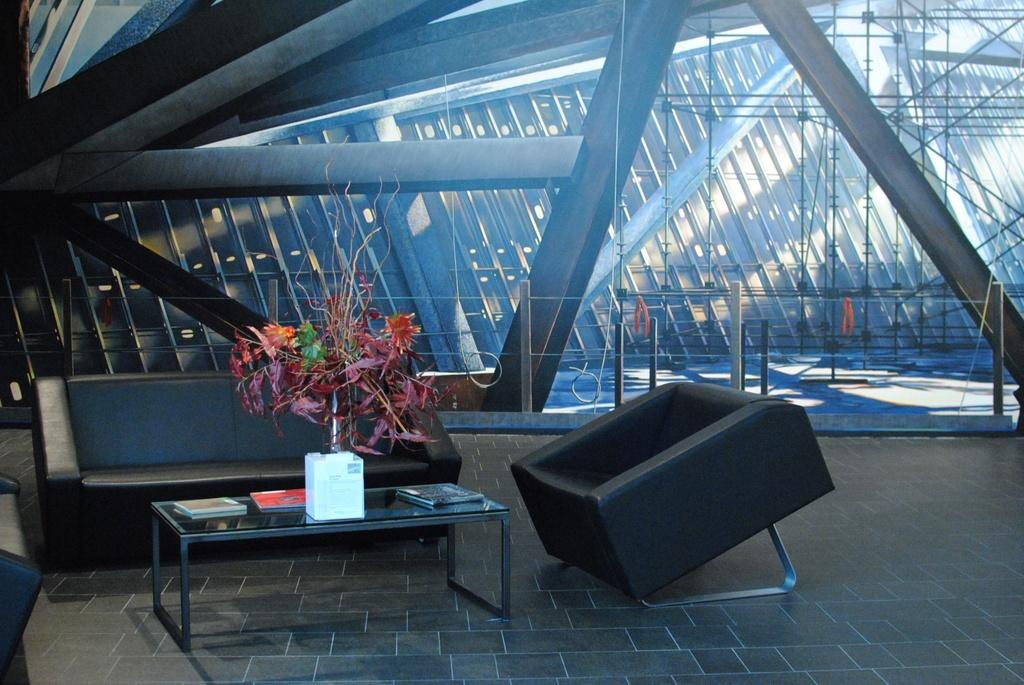What type of furniture is present in the image? There is a sofa set and a table in the image. What is placed on the table? There are books on the table. Is there any greenery in the image? Yes, there is a plant in the image. What type of dress is the plant wearing in the image? There is no dress present in the image, as the plant is a living organism and does not wear clothing. 